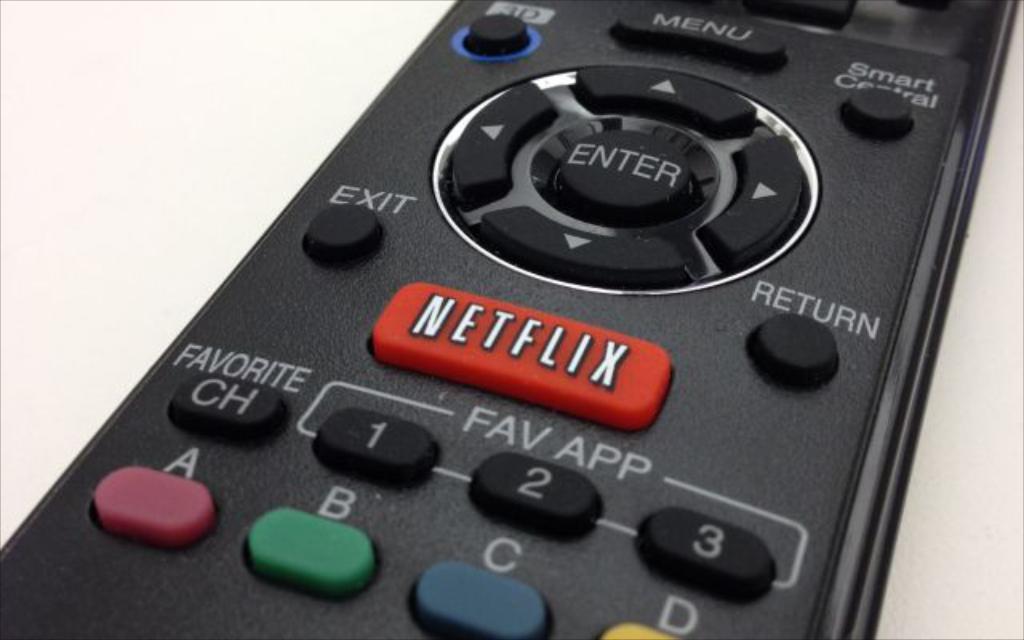What does the red button do?
Make the answer very short. Netflix. Where is the "favorite" button?
Your response must be concise. Below the netflix button. 